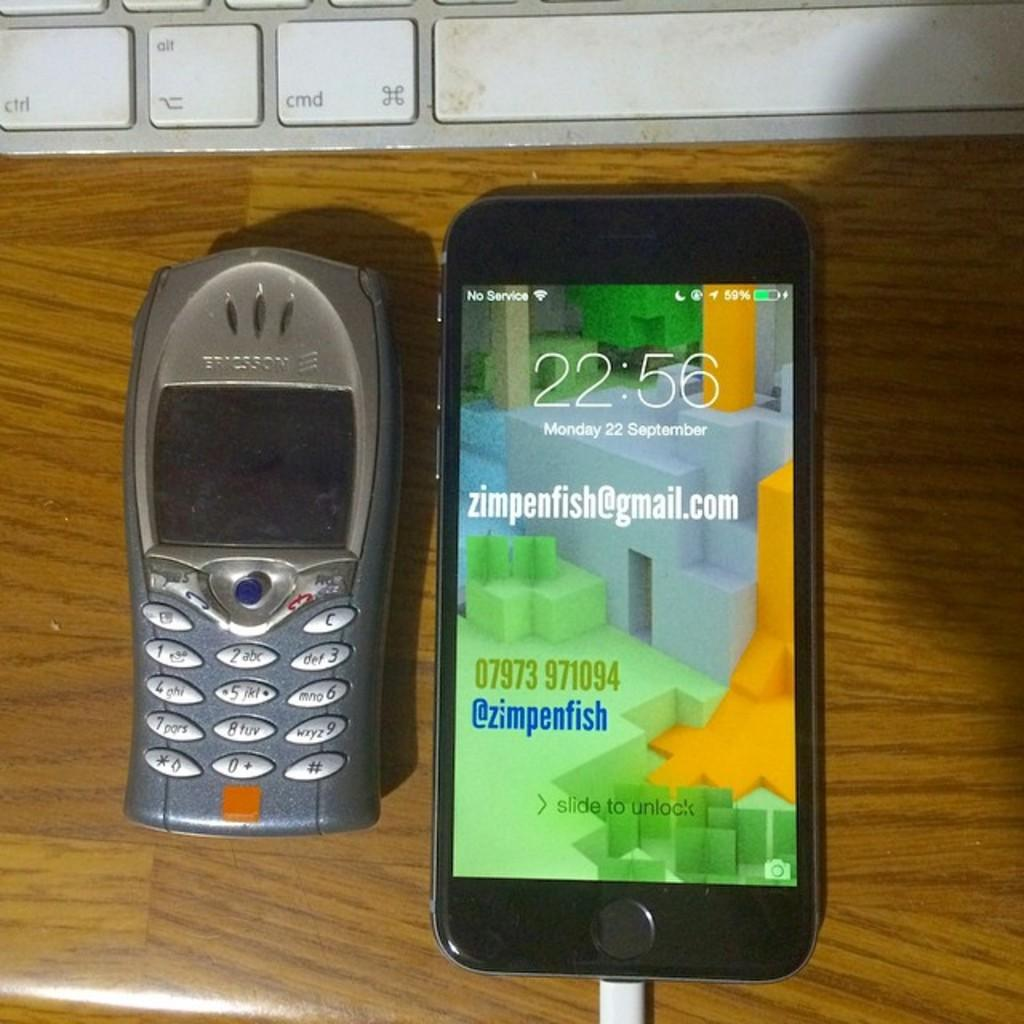<image>
Provide a brief description of the given image. An Ericsson cellphone is on a table next to a smartphone 